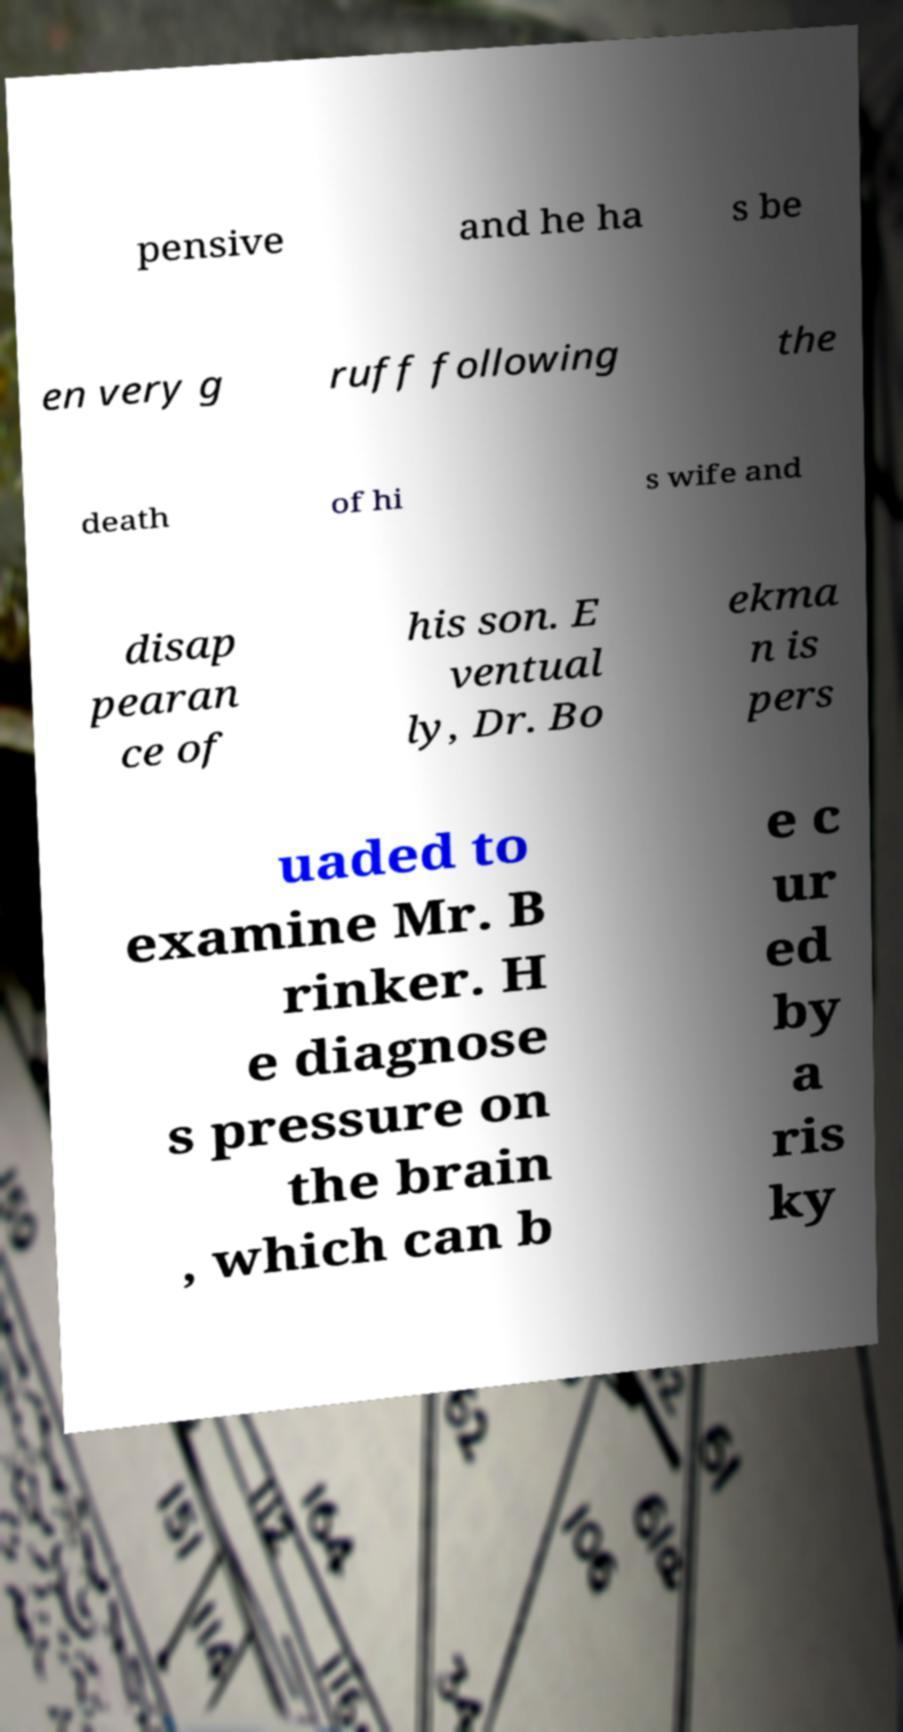Please identify and transcribe the text found in this image. pensive and he ha s be en very g ruff following the death of hi s wife and disap pearan ce of his son. E ventual ly, Dr. Bo ekma n is pers uaded to examine Mr. B rinker. H e diagnose s pressure on the brain , which can b e c ur ed by a ris ky 